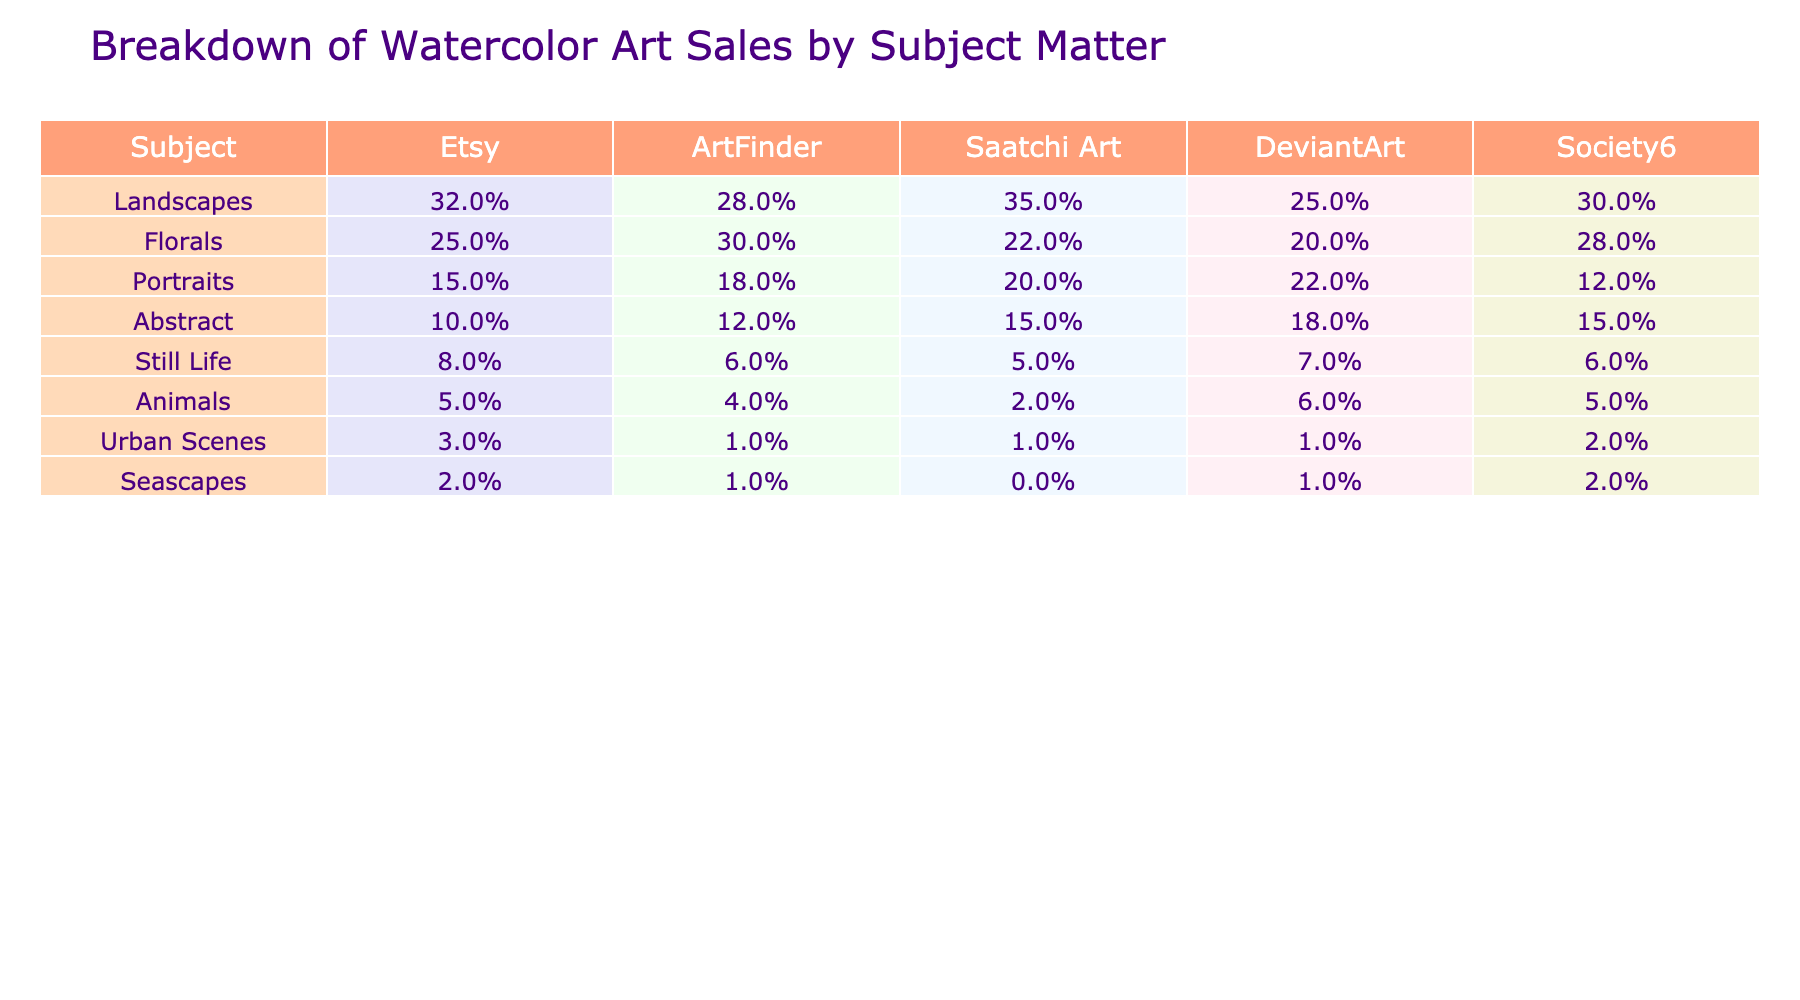What subject matter has the highest sales percentage on Etsy? According to the table, Landscapes have the highest sales percentage on Etsy at 32%.
Answer: 32% Which online marketplace has the lowest sales percentage for Still Life? The table shows that Society6 has the lowest sales percentage for Still Life at 6%.
Answer: 6% What is the difference between the sales percentage of Portraits on Saatchi Art and Society6? The sales percentage for Portraits is 20% on Saatchi Art and 12% on Society6. The difference is 20% - 12% = 8%.
Answer: 8% Is it true that Urban Scenes have more sales percentage on Etsy than Seascapes? Urban Scenes have a sales percentage of 3% on Etsy, while Seascapes have 2%. Since 3% is greater than 2%, the statement is true.
Answer: True What is the average sales percentage for Abstract art across all marketplaces? Adding the sales percentages for Abstract from all platforms: (10% + 12% + 15% + 18% + 15%) = 70%. There are 5 marketplaces, so the average is 70% / 5 = 14%.
Answer: 14% Which subject matter has the highest overall sales percentage when summed across all marketplaces? Summing the percentages for each subject: Landscapes (32 + 28 + 35 + 25 + 30 = 150), Florals (25 + 30 + 22 + 20 + 28 = 125), Portraits (15 + 18 + 20 + 22 + 12 = 87), Abstract (10 + 12 + 15 + 18 + 15 = 70), Still Life (8 + 6 + 5 + 7 + 6 = 32), Animals (5 + 4 + 2 + 6 + 5 = 22), Urban Scenes (3 + 1 + 1 + 1 + 2 = 8), Seascapes (2 + 1 + 0 + 1 + 2 = 6). Landscapes total 150, which is the highest.
Answer: Landscapes What percentage of sales do Animals represent on DeviantArt compared to the overall average percentage of sales for all subject matters in that marketplace? The sales percentage for Animals on DeviantArt is 6%. The average sales percentage for DeviantArt is calculated by summing all percentages (25% + 20% + 22% + 18% + 7% + 6% + 1% + 1% = 100%) and dividing by 8, which equals 12.5%. Since 6% is less than 12.5%, Animals represent below-average sales on DeviantArt.
Answer: Below average Which subject matter is the least popular on Society6? According to the table, Animals have the lowest sales percentage on Society6 at 5%.
Answer: 5% 